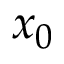Convert formula to latex. <formula><loc_0><loc_0><loc_500><loc_500>x _ { 0 }</formula> 